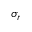<formula> <loc_0><loc_0><loc_500><loc_500>\sigma _ { r }</formula> 